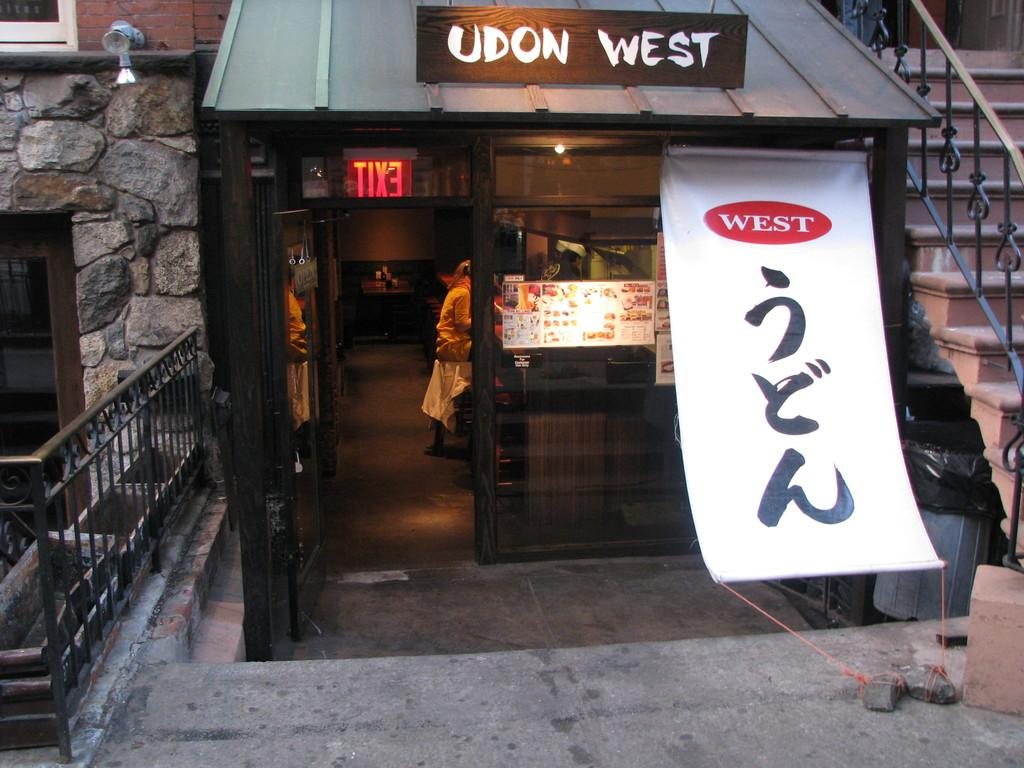Provide a one-sentence caption for the provided image. A small restaurant front with an Udon West sign atop it. 